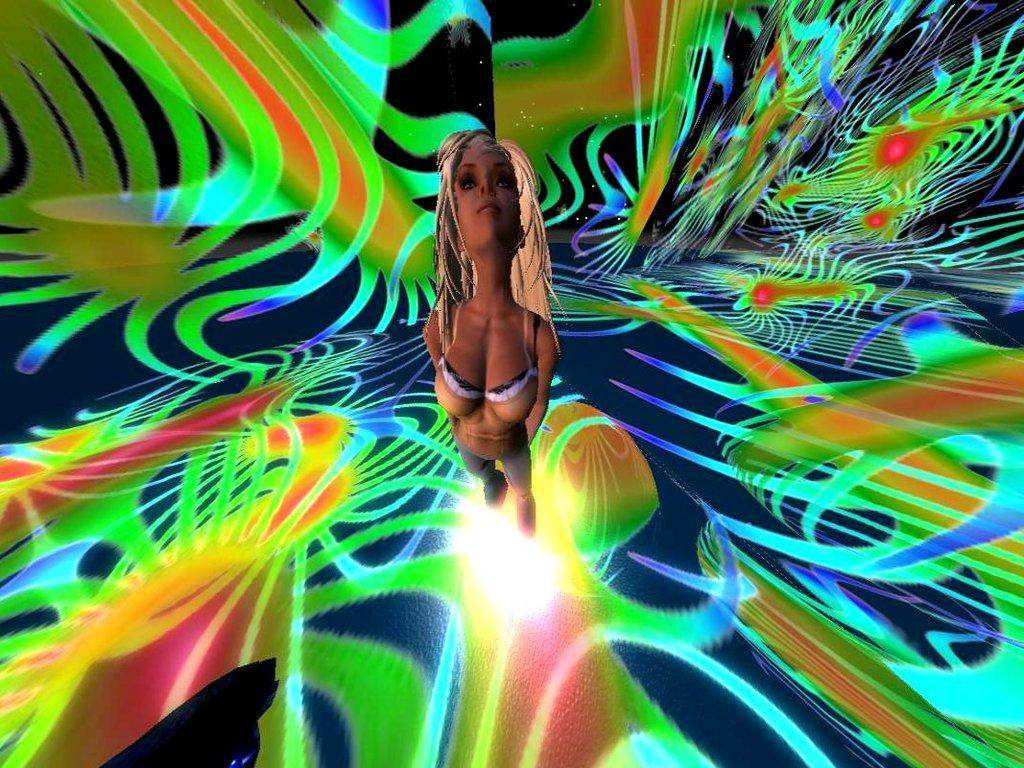Who is the main subject in the image? There is a girl in the image. What is the girl standing among? The girl is standing in the middle of colorful things. What is the girl wearing? The girl is wearing a brown dress. What type of treatment is the girl receiving in the image? There is no indication in the image that the girl is receiving any treatment. 